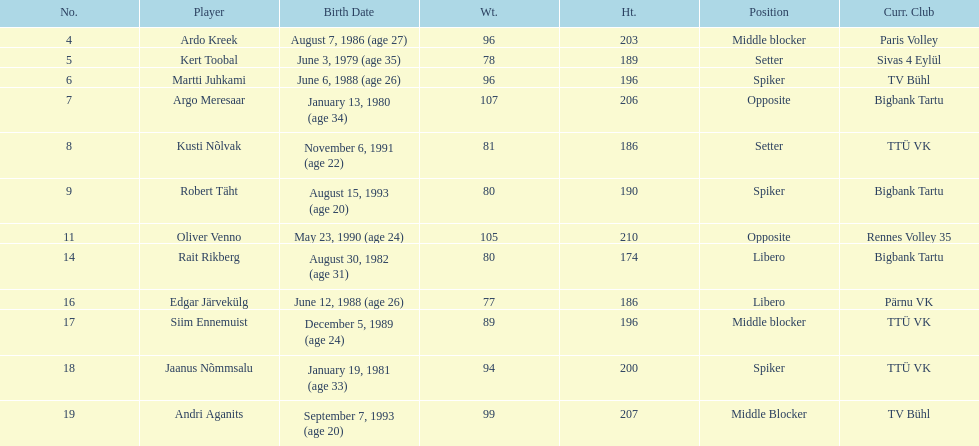Kert toobal is the oldest who is the next oldest player listed? Argo Meresaar. 